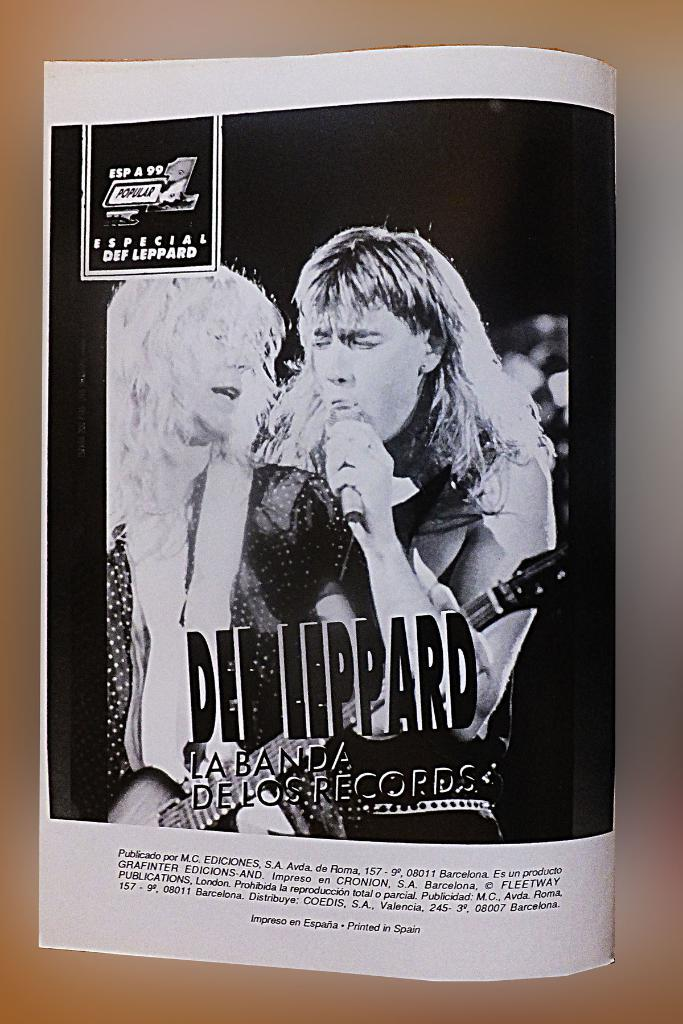<image>
Write a terse but informative summary of the picture. A Spanish language article takes a look at heavy metal icons Def Leppard. 